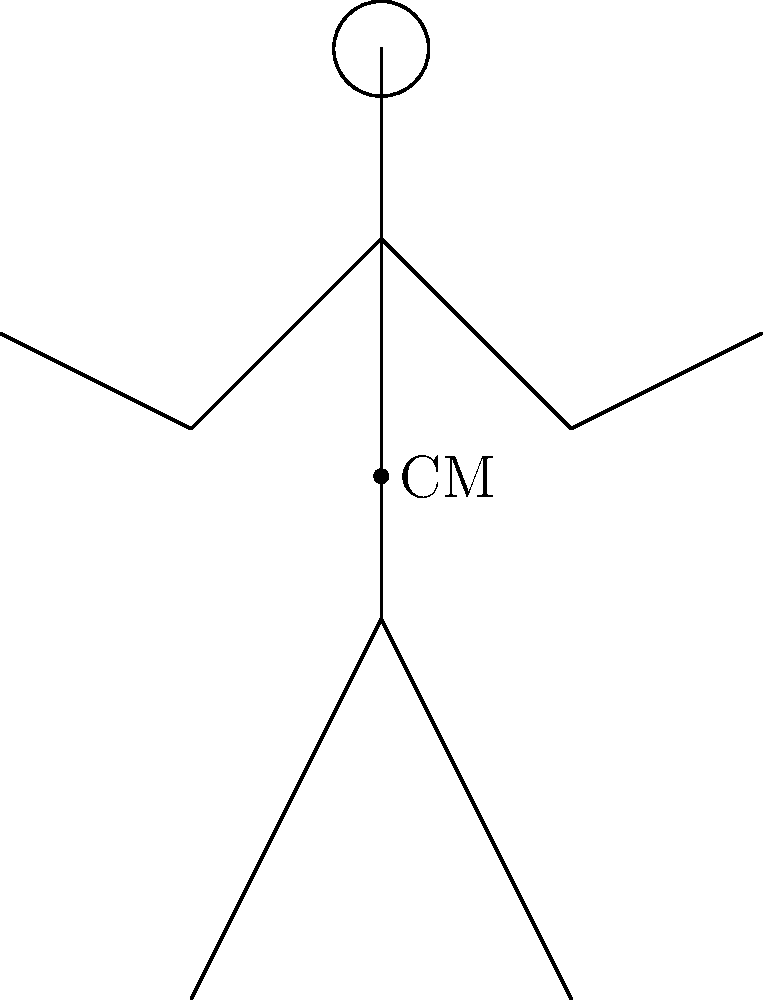As a financial literacy trainer, you want to use a biomechanics analogy to explain risk distribution in investment portfolios. Consider the stick figure diagram representing a standing human. If the center of mass (CM) is located at approximately 55% of the person's height from the ground, what would be the y-coordinate of the CM if the total height of the person is 10 units? To solve this problem, we'll follow these steps:

1. Understand the given information:
   - The stick figure represents a standing human
   - The total height of the person is 10 units
   - The center of mass (CM) is located at approximately 55% of the person's height from the ground

2. Calculate the y-coordinate of the CM:
   - Let's use the formula: $y_{CM} = h \times p$
   Where:
   $y_{CM}$ = y-coordinate of the center of mass
   $h$ = total height of the person
   $p$ = percentage of height from the ground

3. Plug in the values:
   $y_{CM} = 10 \times 0.55$

4. Calculate the result:
   $y_{CM} = 5.5$

Therefore, the y-coordinate of the center of mass would be 5.5 units from the ground.

This analogy can be used to explain that just as the center of mass represents the balance point of the body, a well-diversified investment portfolio aims to find a balance between risk and return, often located around the middle of the risk spectrum.
Answer: 5.5 units 